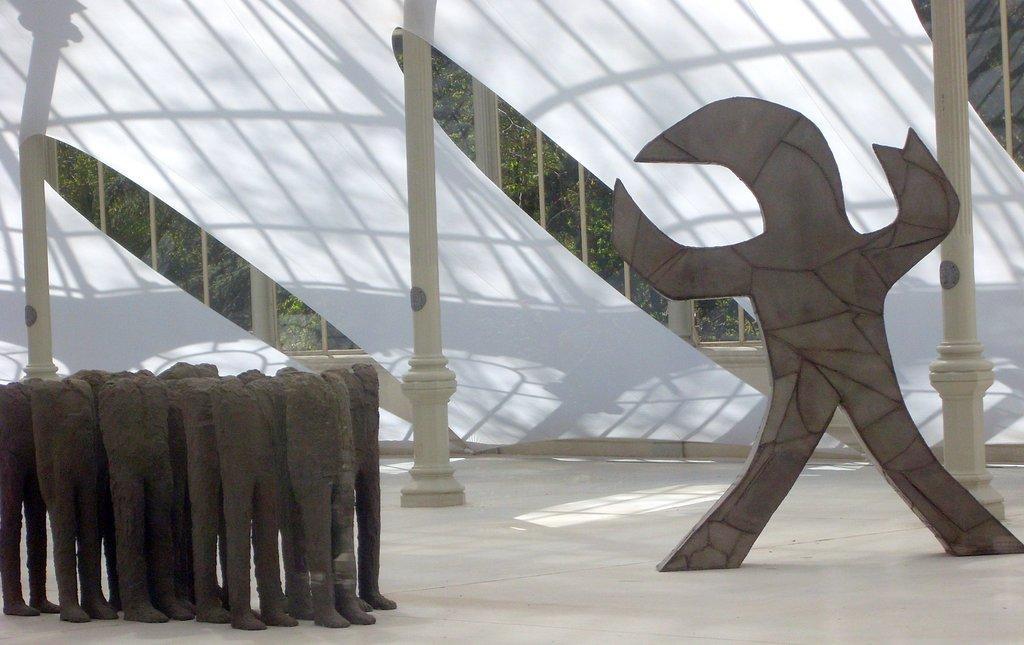What type of sculptures can be seen in the image? There are pant sculptures in the image. What other structures are present in the image besides the sculptures? There are three white poles with a tent cloth in the image. What type of natural elements can be seen in the image? Trees are visible in the image. Can you tell me how many chess pieces are on the table in the image? There is no table or chess pieces present in the image. What type of stranger is standing near the sculptures in the image? There is no stranger present in the image. 